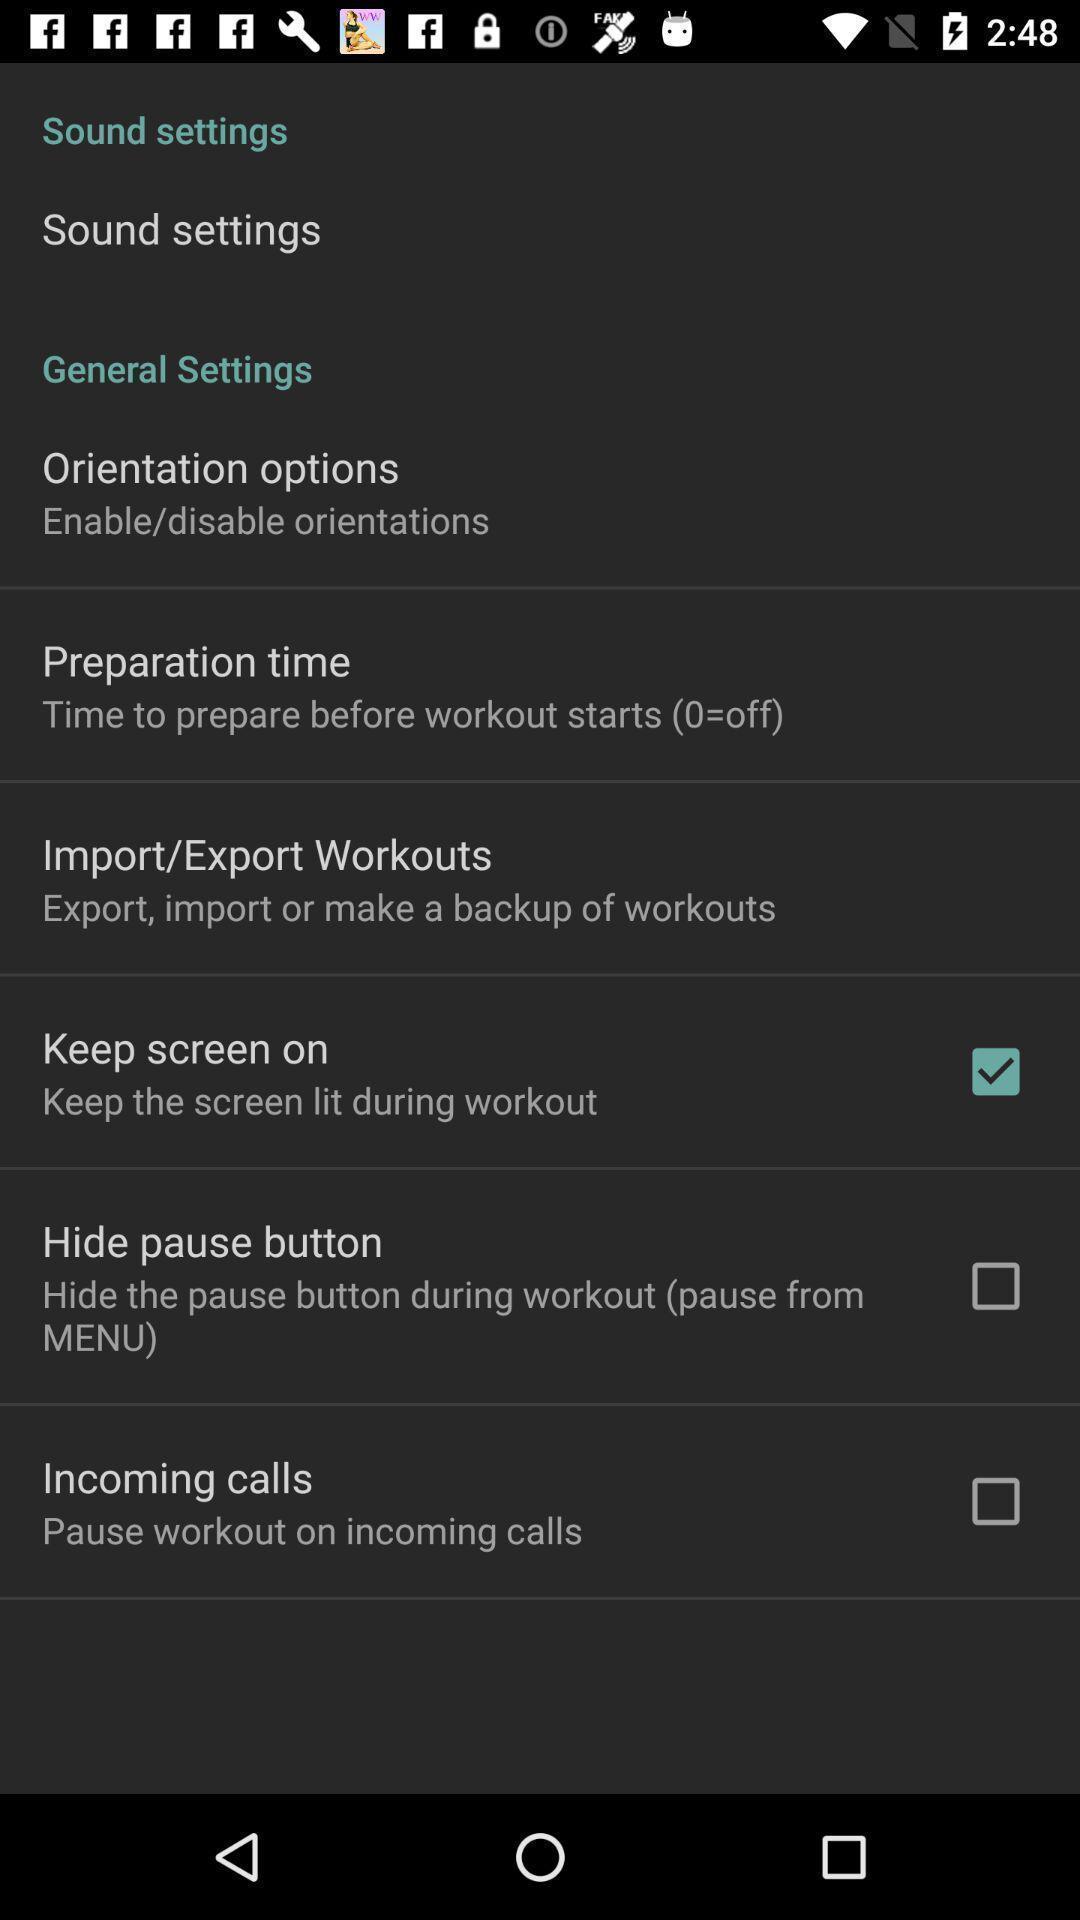What can you discern from this picture? Screen displaying multiple options in settings page. 